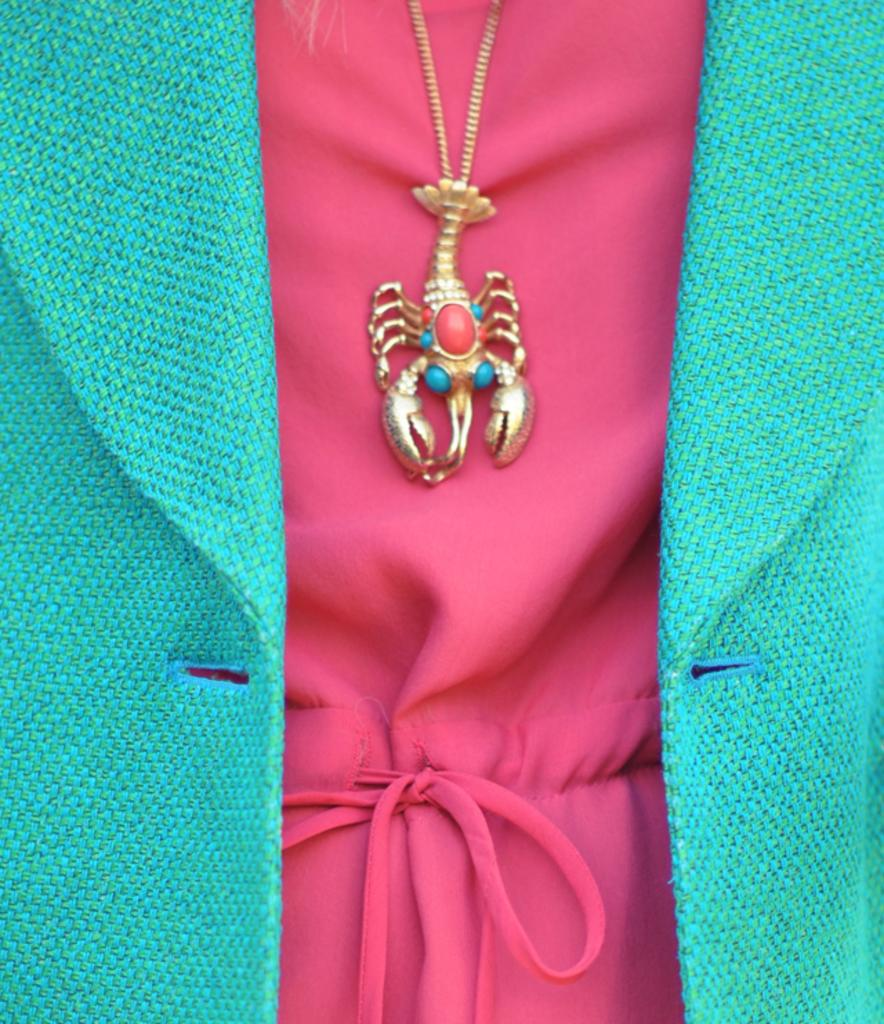What type of clothing is in the foreground of the image? There is a pink dress and a green coat in the foreground of the image. What accessory is also present in the foreground of the image? There is a Scorpio locket in the foreground of the image. What type of bait is being used to catch fish in the image? There is no bait or fishing activity present in the image. What type of rose can be seen in the image? There is no rose present in the image. What type of musical instrument is being played in the image? There is no musical instrument or indication of music being played in the image. 